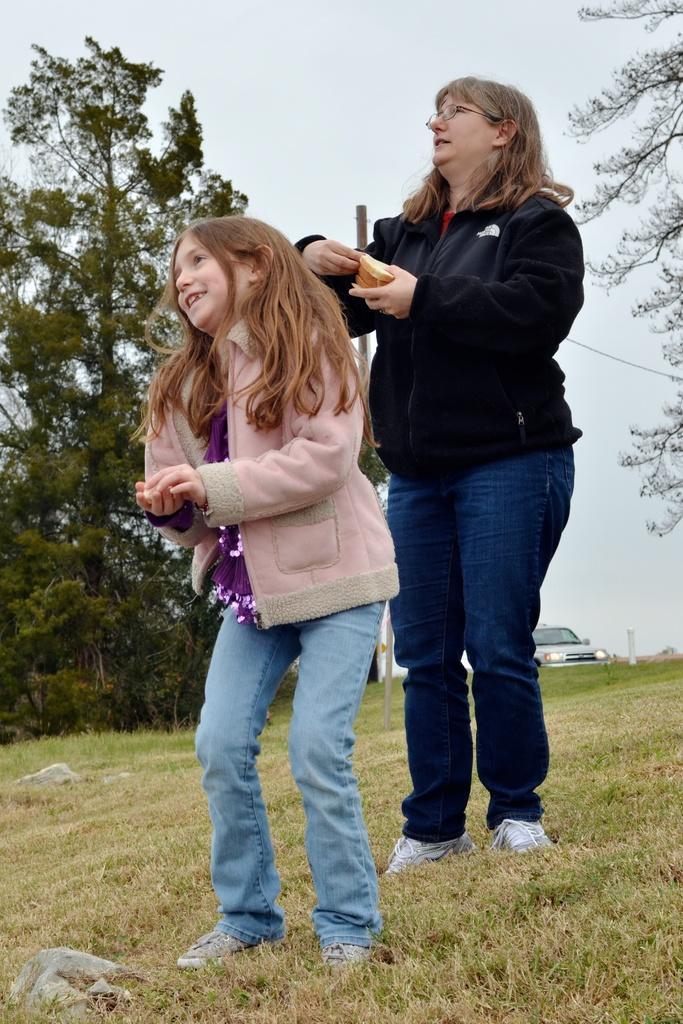Please provide a concise description of this image. In this picture there is a lady and a girl in the center of the image, on the grassland and there is a car and a tree in the background area of the image. 